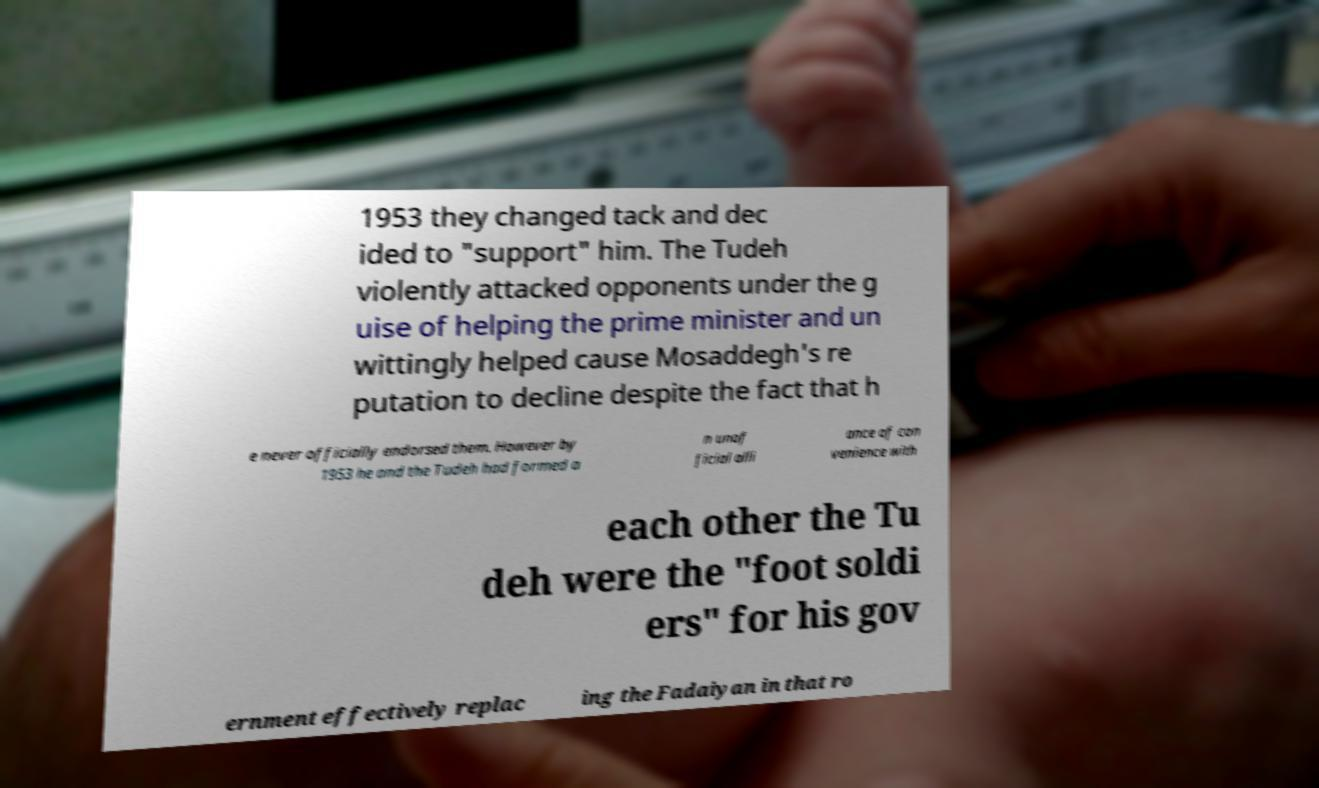Please identify and transcribe the text found in this image. 1953 they changed tack and dec ided to "support" him. The Tudeh violently attacked opponents under the g uise of helping the prime minister and un wittingly helped cause Mosaddegh's re putation to decline despite the fact that h e never officially endorsed them. However by 1953 he and the Tudeh had formed a n unof ficial alli ance of con venience with each other the Tu deh were the "foot soldi ers" for his gov ernment effectively replac ing the Fadaiyan in that ro 